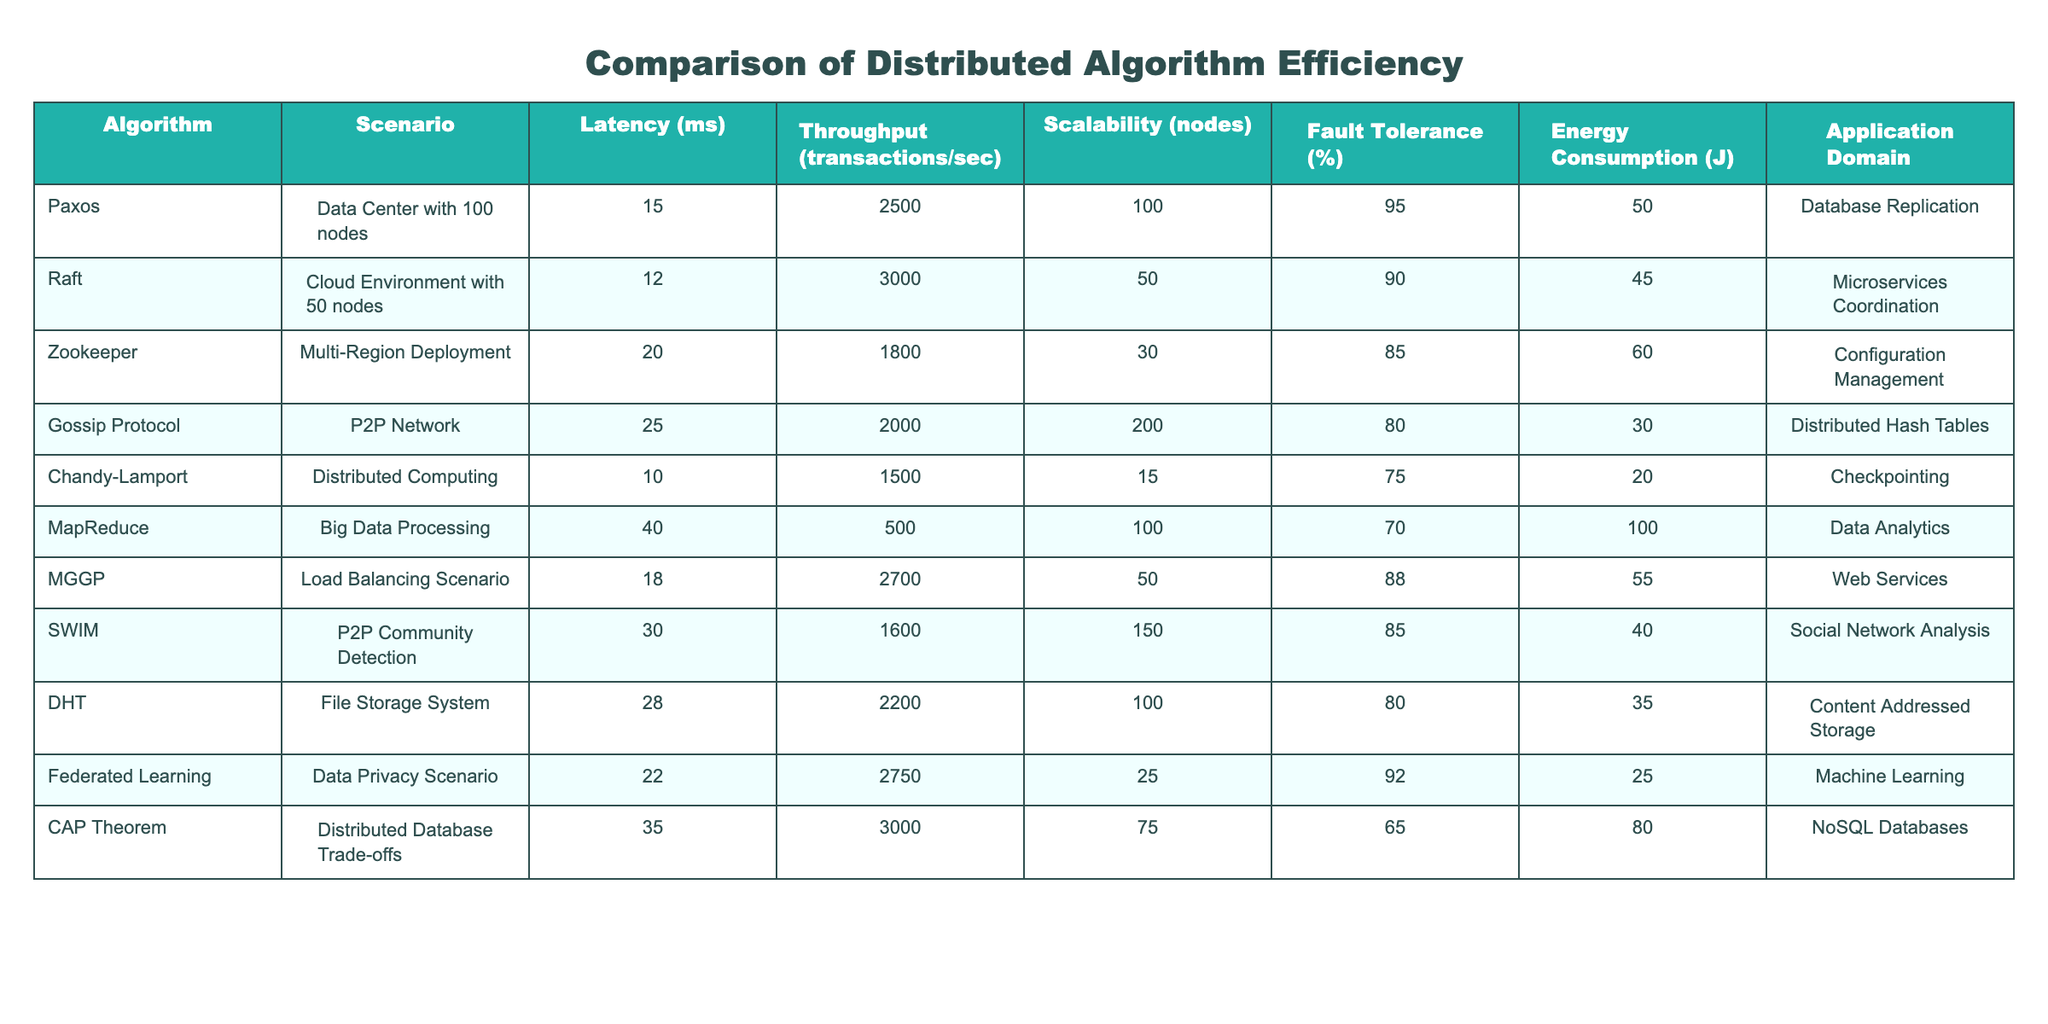What is the latency of the Raft algorithm? The table shows that the latency for the Raft algorithm is listed under the "Latency (ms)" column as 12 ms.
Answer: 12 ms Which algorithm has the highest throughput and what is that value? Looking at the "Throughput (transactions/sec)" column, the algorithm with the highest throughput is CAP Theorem with a throughput of 3000 transactions/sec.
Answer: CAP Theorem, 3000 transactions/sec What is the average latency of all the algorithms listed? To find the average latency, sum all latency values (15 + 12 + 20 + 25 + 10 + 40 + 18 + 30 + 28 + 22 + 35) =  305 ms, then divide by the number of algorithms, which is 11: 305 / 11 = 27.73 ms.
Answer: 27.73 ms Is there any algorithm with more than 100 nodes scalability? By checking the "Scalability (nodes)" column, both Paxos and Gossip Protocol have scalability over 100 nodes (100 and 200 respectively). Therefore, the answer is yes.
Answer: Yes What is the difference in energy consumption between the Chandy-Lamport and Zookeeper algorithms? From the "Energy Consumption (J)" column, Chandy-Lamport has 20 J and Zookeeper has 60 J. The difference is calculated as 60 - 20 = 40 J.
Answer: 40 J Which algorithm has the lowest fault tolerance percentage, and what is that value? By examining the "Fault Tolerance (%)" column, Chandy-Lamport has the lowest value at 75%.
Answer: 75% What is the maximum scalability among all the algorithms and which one does it belong to? The "Scalability (nodes)" column shows Paxos and DHT as having the maximum value of 100 nodes, hence Paxos is one of them.
Answer: 100 nodes, Paxos How much more energy does MapReduce consume compared to Federated Learning? The energy consumption for MapReduce is 100 J and for Federated Learning, it is 25 J. The difference, 100 - 25, is 75 J.
Answer: 75 J Which application domain has the highest fault tolerance percentage, and what is that percentage? Checking the "Fault Tolerance (%)" corresponding to different algorithms reveals that Paxos has the highest fault tolerance percentage, which is 95%.
Answer: Database Replication, 95% What is the relationship between energy consumption and scalability in the context of these algorithms? To analyze this, observe that higher energy consumption (e.g., MapReduce at 100 J) does not correlate with higher scalability (maximum scalability is 200 for Gossip Protocol at 30 J), but rather different algorithms prioritize different aspects. A detailed evaluation reveals that energy consumption can vary independently of scalability.
Answer: Energy consumption and scalability are independent 